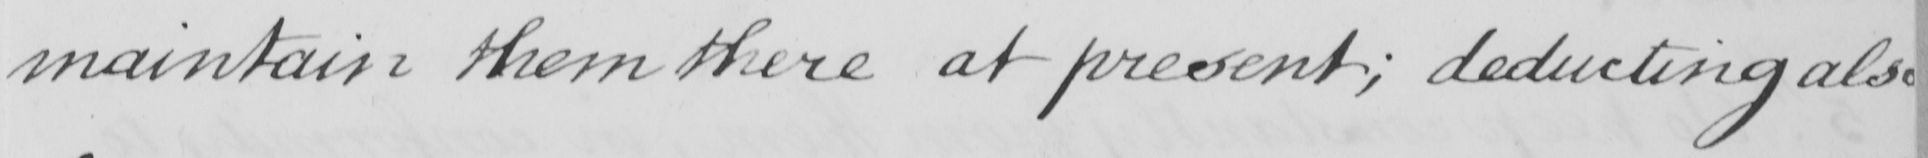What text is written in this handwritten line? maintain them there at present ; deducting also 